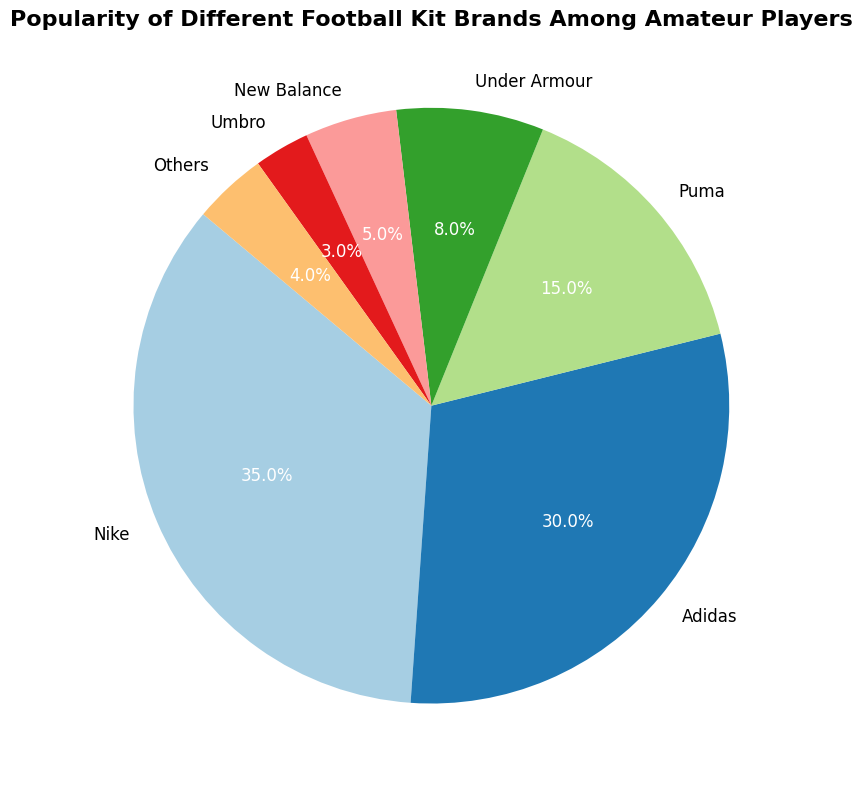Which brand has the highest popularity among amateur players? According to the pie chart, the brand with the largest slice is Nike, with 35% of the popularity.
Answer: Nike Which two brands combined have a popularity equal to or greater than Nike? Nike has 35% popularity. Adidas has 30%, and Puma has 15%. Combining Adidas (30%) and Puma (15%) gives 45%, which is greater than Nike's 35%.
Answer: Adidas and Puma What is the total percentage of players using brands other than Nike and Adidas? Nike and Adidas together have 35% + 30% = 65%. The total percentage is 100%, so the percentage of players using other brands is 100% - 65% = 35%.
Answer: 35% Which brands are less popular than Under Armour? According to the chart, the brands less popular than Under Armour (8%) are New Balance (5%), Umbro (3%), and Others (4%).
Answer: New Balance, Umbro, and Others What is the combined popularity of the three least popular brands? The three least popular brands are Umbro (3%), Others (4%), and New Balance (5%). The combined popularity is 3% + 4% + 5% = 12%.
Answer: 12% Which brand has a popularity closest to one-third of the total? The total percentage is 100%, so one-third is approximately 33.33%. Comparing the given percentages, Adidas with 30% is closest to one-third.
Answer: Adidas How much more popular is Nike compared to Puma? Nike has 35% and Puma has 15%. The difference in popularity is 35% - 15% = 20%.
Answer: 20% Are the combined popularity percentages of Puma and Under Armour greater than that of Adidas? Puma has 15% and Under Armour has 8%. Their combined percentage is 15% + 8% = 23%. Adidas has 30%, so Puma and Under Armour combined are less than Adidas.
Answer: No What is the average popularity of brands excluding Nike and Adidas? The remaining brands are Puma (15%), Under Armour (8%), New Balance (5%), Umbro (3%), and Others (4%). Adding these gives 15% + 8% + 5% + 3% + 4% = 35%. There are 5 brands, so the average is 35% / 5 = 7%.
Answer: 7% Which brand has the smallest slice in the pie chart? According to the pie chart, Umbro has the smallest slice with 3% popularity.
Answer: Umbro 